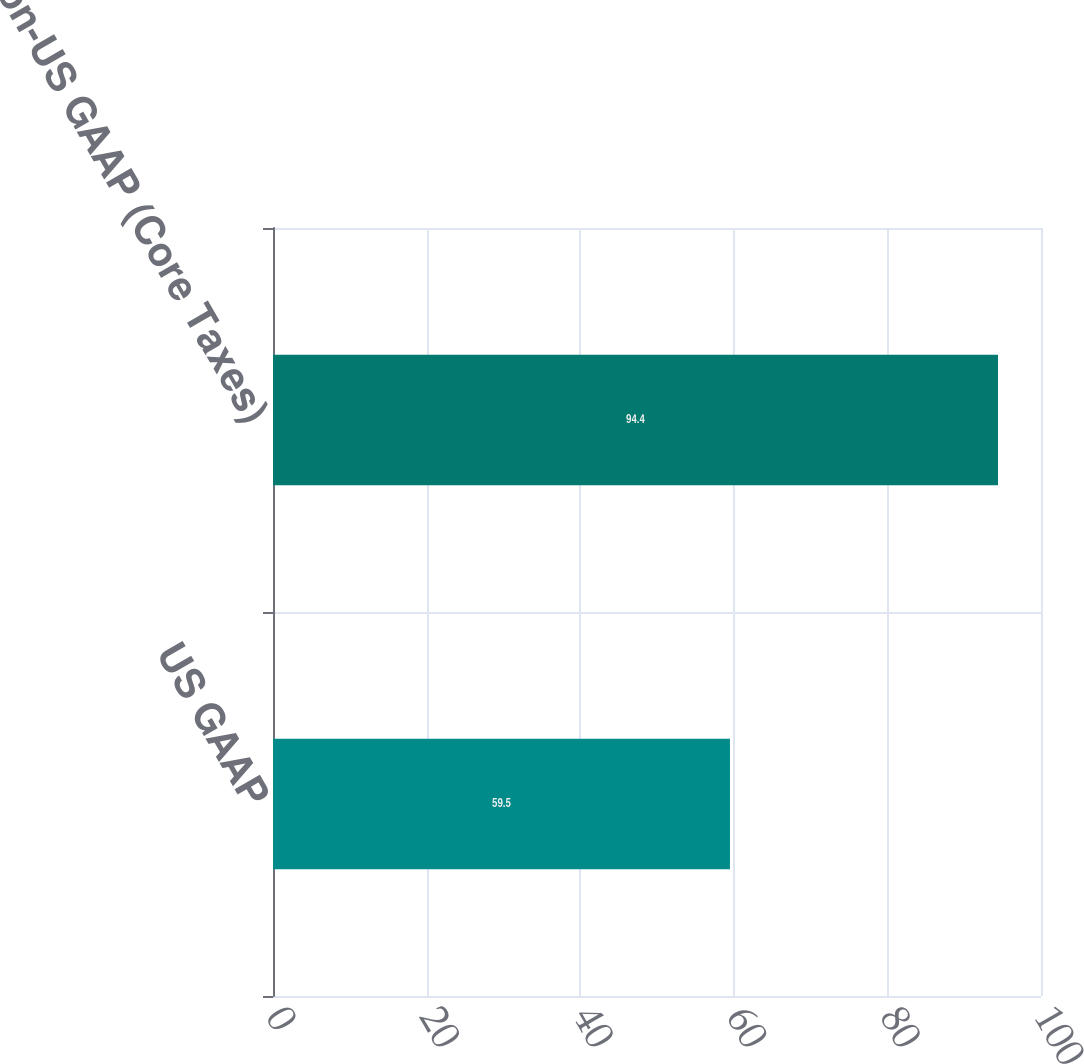<chart> <loc_0><loc_0><loc_500><loc_500><bar_chart><fcel>US GAAP<fcel>Non-US GAAP (Core Taxes)<nl><fcel>59.5<fcel>94.4<nl></chart> 